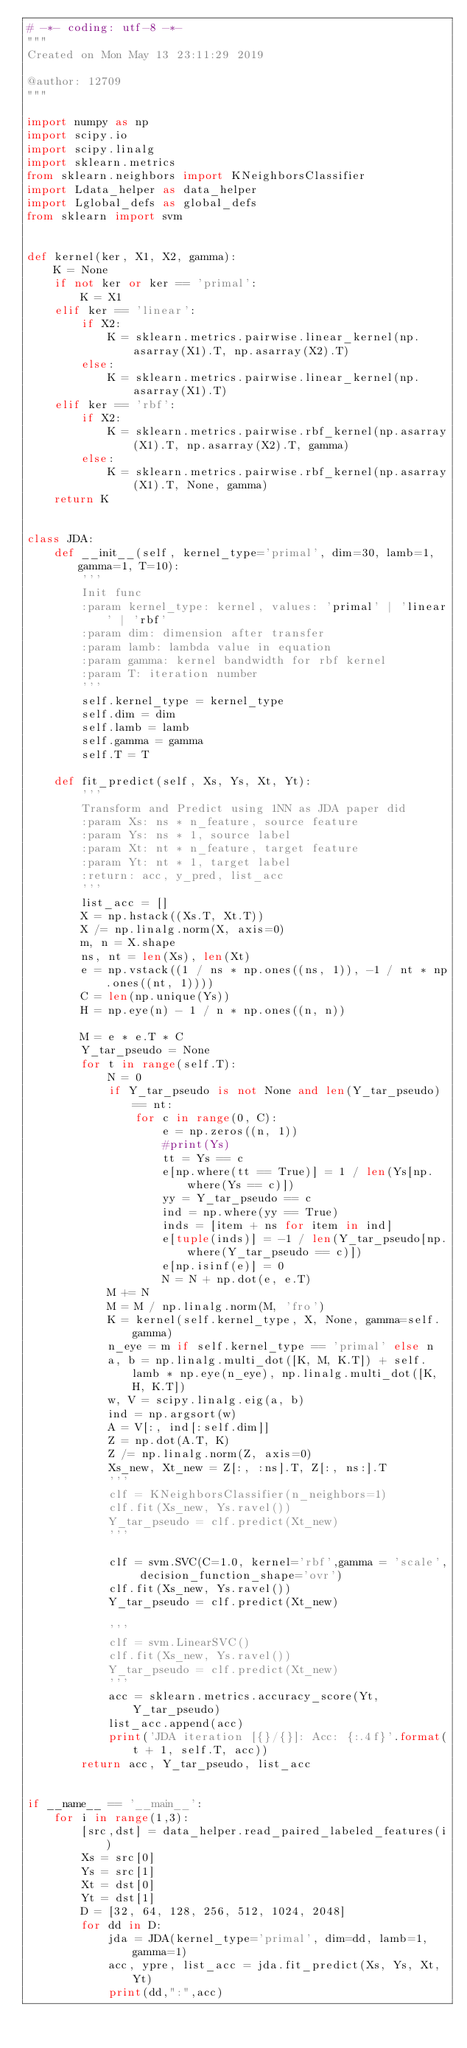Convert code to text. <code><loc_0><loc_0><loc_500><loc_500><_Python_># -*- coding: utf-8 -*-
"""
Created on Mon May 13 23:11:29 2019

@author: 12709
"""

import numpy as np
import scipy.io
import scipy.linalg
import sklearn.metrics
from sklearn.neighbors import KNeighborsClassifier
import Ldata_helper as data_helper
import Lglobal_defs as global_defs
from sklearn import svm


def kernel(ker, X1, X2, gamma):
    K = None
    if not ker or ker == 'primal':
        K = X1
    elif ker == 'linear':
        if X2:
            K = sklearn.metrics.pairwise.linear_kernel(np.asarray(X1).T, np.asarray(X2).T)
        else:
            K = sklearn.metrics.pairwise.linear_kernel(np.asarray(X1).T)
    elif ker == 'rbf':
        if X2:
            K = sklearn.metrics.pairwise.rbf_kernel(np.asarray(X1).T, np.asarray(X2).T, gamma)
        else:
            K = sklearn.metrics.pairwise.rbf_kernel(np.asarray(X1).T, None, gamma)
    return K


class JDA:
    def __init__(self, kernel_type='primal', dim=30, lamb=1, gamma=1, T=10):
        '''
        Init func
        :param kernel_type: kernel, values: 'primal' | 'linear' | 'rbf'
        :param dim: dimension after transfer
        :param lamb: lambda value in equation
        :param gamma: kernel bandwidth for rbf kernel
        :param T: iteration number
        '''
        self.kernel_type = kernel_type
        self.dim = dim
        self.lamb = lamb
        self.gamma = gamma
        self.T = T

    def fit_predict(self, Xs, Ys, Xt, Yt):
        '''
        Transform and Predict using 1NN as JDA paper did
        :param Xs: ns * n_feature, source feature
        :param Ys: ns * 1, source label
        :param Xt: nt * n_feature, target feature
        :param Yt: nt * 1, target label
        :return: acc, y_pred, list_acc
        '''
        list_acc = []
        X = np.hstack((Xs.T, Xt.T))
        X /= np.linalg.norm(X, axis=0)
        m, n = X.shape
        ns, nt = len(Xs), len(Xt)
        e = np.vstack((1 / ns * np.ones((ns, 1)), -1 / nt * np.ones((nt, 1))))
        C = len(np.unique(Ys))
        H = np.eye(n) - 1 / n * np.ones((n, n))

        M = e * e.T * C
        Y_tar_pseudo = None
        for t in range(self.T):
            N = 0
            if Y_tar_pseudo is not None and len(Y_tar_pseudo) == nt:
                for c in range(0, C):
                    e = np.zeros((n, 1))
                    #print(Ys)
                    tt = Ys == c
                    e[np.where(tt == True)] = 1 / len(Ys[np.where(Ys == c)])
                    yy = Y_tar_pseudo == c
                    ind = np.where(yy == True)
                    inds = [item + ns for item in ind]
                    e[tuple(inds)] = -1 / len(Y_tar_pseudo[np.where(Y_tar_pseudo == c)])
                    e[np.isinf(e)] = 0
                    N = N + np.dot(e, e.T)
            M += N
            M = M / np.linalg.norm(M, 'fro')
            K = kernel(self.kernel_type, X, None, gamma=self.gamma)
            n_eye = m if self.kernel_type == 'primal' else n
            a, b = np.linalg.multi_dot([K, M, K.T]) + self.lamb * np.eye(n_eye), np.linalg.multi_dot([K, H, K.T])
            w, V = scipy.linalg.eig(a, b)
            ind = np.argsort(w)
            A = V[:, ind[:self.dim]]
            Z = np.dot(A.T, K)
            Z /= np.linalg.norm(Z, axis=0)
            Xs_new, Xt_new = Z[:, :ns].T, Z[:, ns:].T
            '''
            clf = KNeighborsClassifier(n_neighbors=1)
            clf.fit(Xs_new, Ys.ravel())
            Y_tar_pseudo = clf.predict(Xt_new)
            '''
            
            clf = svm.SVC(C=1.0, kernel='rbf',gamma = 'scale', decision_function_shape='ovr')
            clf.fit(Xs_new, Ys.ravel())
            Y_tar_pseudo = clf.predict(Xt_new)
            
            '''
            clf = svm.LinearSVC()
            clf.fit(Xs_new, Ys.ravel())
            Y_tar_pseudo = clf.predict(Xt_new)
            '''
            acc = sklearn.metrics.accuracy_score(Yt, Y_tar_pseudo)
            list_acc.append(acc)
            print('JDA iteration [{}/{}]: Acc: {:.4f}'.format(t + 1, self.T, acc))
        return acc, Y_tar_pseudo, list_acc


if __name__ == '__main__':
    for i in range(1,3):
        [src,dst] = data_helper.read_paired_labeled_features(i)
        Xs = src[0]
        Ys = src[1]
        Xt = dst[0]
        Yt = dst[1]
        D = [32, 64, 128, 256, 512, 1024, 2048]
        for dd in D:
            jda = JDA(kernel_type='primal', dim=dd, lamb=1, gamma=1)
            acc, ypre, list_acc = jda.fit_predict(Xs, Ys, Xt, Yt)
            print(dd,":",acc)

    </code> 